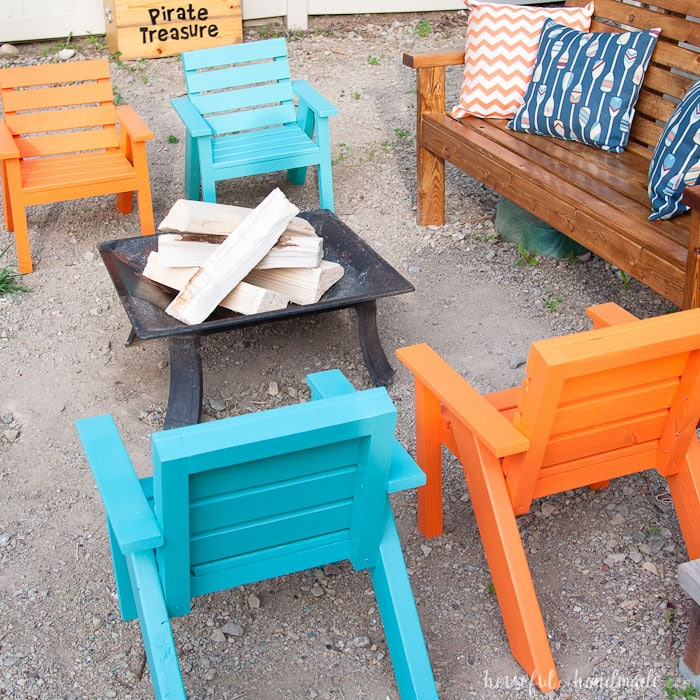What types of activities might guests enjoy during this event? Guests might enjoy various engaging activities like roasting marshmallows and making s'mores over the fire pit, sharing stories or playing acoustic music, or participating in a treasure hunt inspired by the 'Pirate Treasure' sign. Additionally, casual conversation and relaxation would be enhanced by the comfortable seating arrangement and cozy ambiance. How can the host further enhance the experience for guests? To further enhance the experience, the host could provide warm blankets for guests to use as the evening cools, string up fairy lights for added ambiance, and offer a variety of snacks and beverages. Organizing a themed activity or game, such as a scavenger hunt or storytelling session, can also add an element of fun. Soft background music could contribute to creating a more inviting atmosphere. 